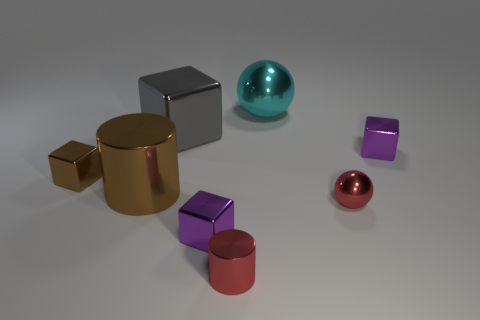Subtract all small metal cubes. How many cubes are left? 1 Add 1 red metal cylinders. How many objects exist? 9 Subtract all brown cylinders. How many cylinders are left? 1 Subtract all spheres. How many objects are left? 6 Subtract 2 cylinders. How many cylinders are left? 0 Subtract 1 red cylinders. How many objects are left? 7 Subtract all green cylinders. Subtract all green blocks. How many cylinders are left? 2 Subtract all cyan cylinders. How many gray cubes are left? 1 Subtract all big gray shiny objects. Subtract all small yellow objects. How many objects are left? 7 Add 1 small objects. How many small objects are left? 6 